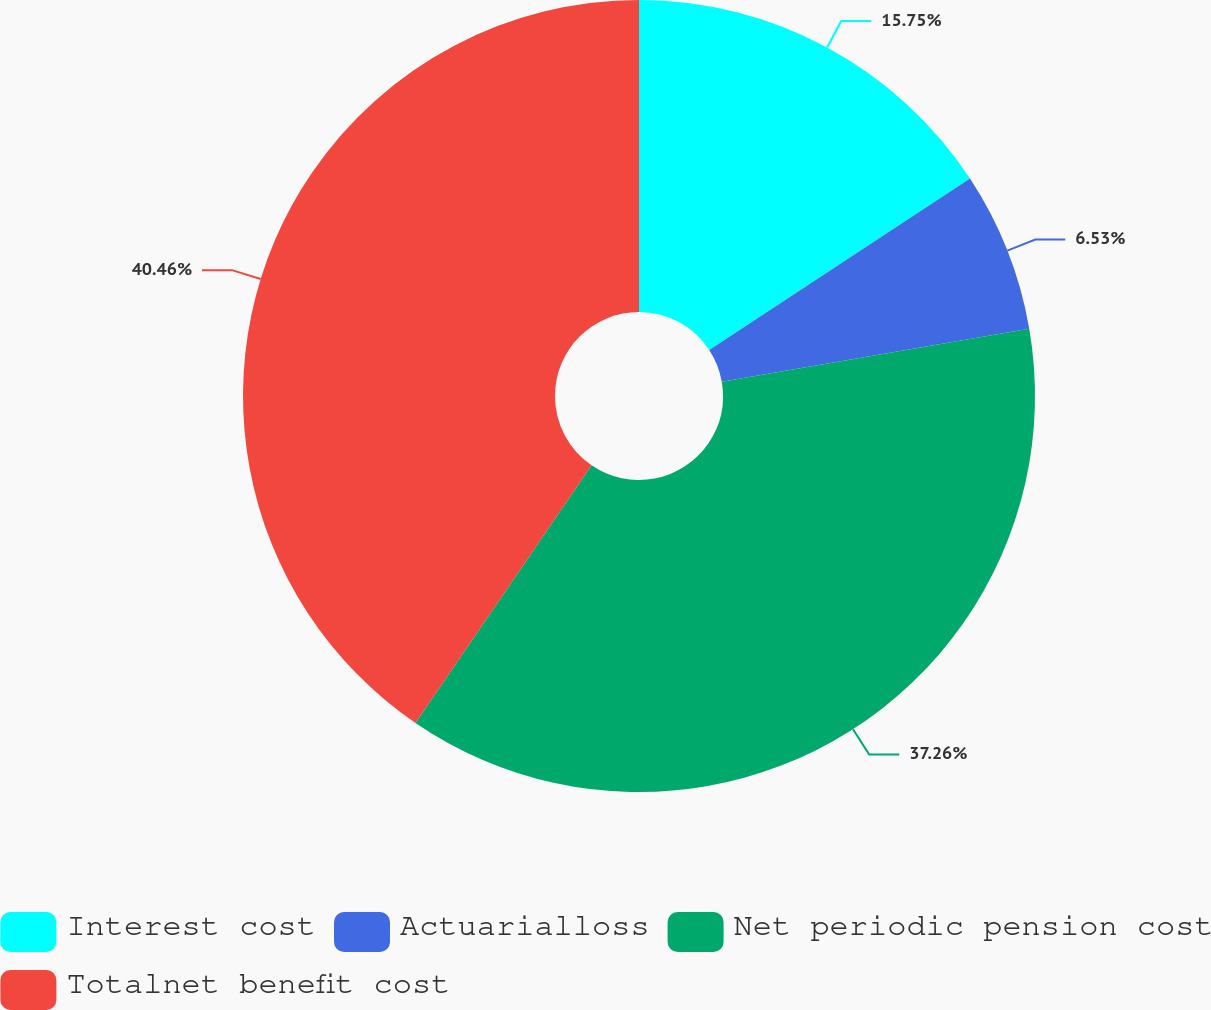Convert chart. <chart><loc_0><loc_0><loc_500><loc_500><pie_chart><fcel>Interest cost<fcel>Actuarialloss<fcel>Net periodic pension cost<fcel>Totalnet benefit cost<nl><fcel>15.75%<fcel>6.53%<fcel>37.26%<fcel>40.45%<nl></chart> 